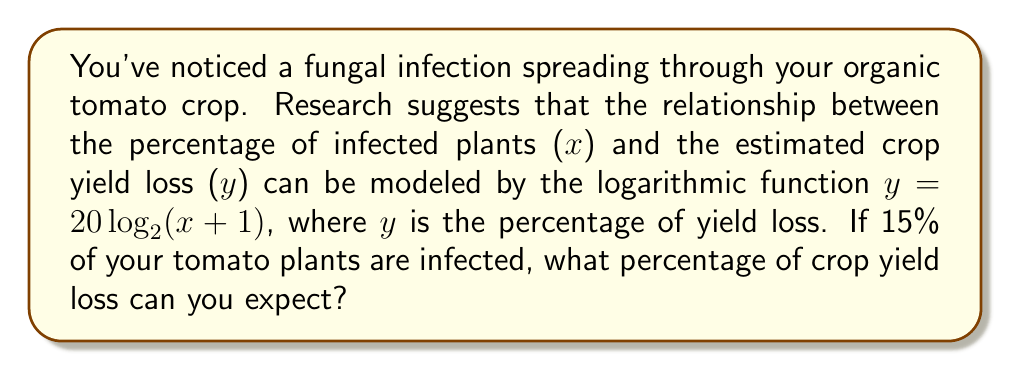What is the answer to this math problem? To solve this problem, we'll follow these steps:

1. Identify the given information:
   - The function relating infected plants (x) to yield loss (y) is:
     $y = 20\log_2(x + 1)$
   - The percentage of infected plants (x) is 15%

2. Substitute x = 15 into the function:
   $y = 20\log_2(15 + 1)$
   $y = 20\log_2(16)$

3. Simplify the logarithm:
   $\log_2(16) = 4$ (since $2^4 = 16$)

4. Calculate the final result:
   $y = 20 \cdot 4 = 80$

Therefore, with 15% of tomato plants infected, you can expect an 80% crop yield loss.
Answer: 80% 